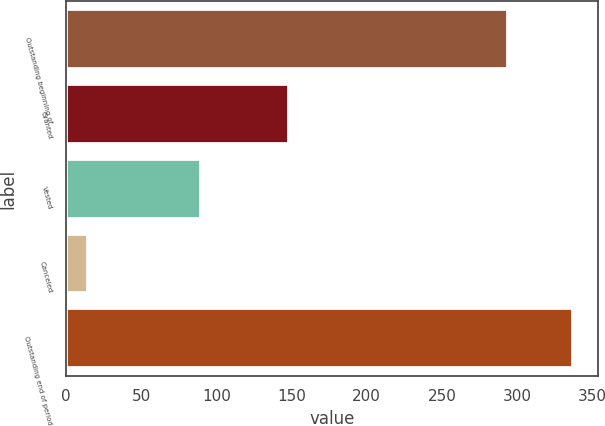Convert chart to OTSL. <chart><loc_0><loc_0><loc_500><loc_500><bar_chart><fcel>Outstanding beginning of<fcel>Granted<fcel>Vested<fcel>Canceled<fcel>Outstanding end of period<nl><fcel>294<fcel>148<fcel>90<fcel>15<fcel>337<nl></chart> 